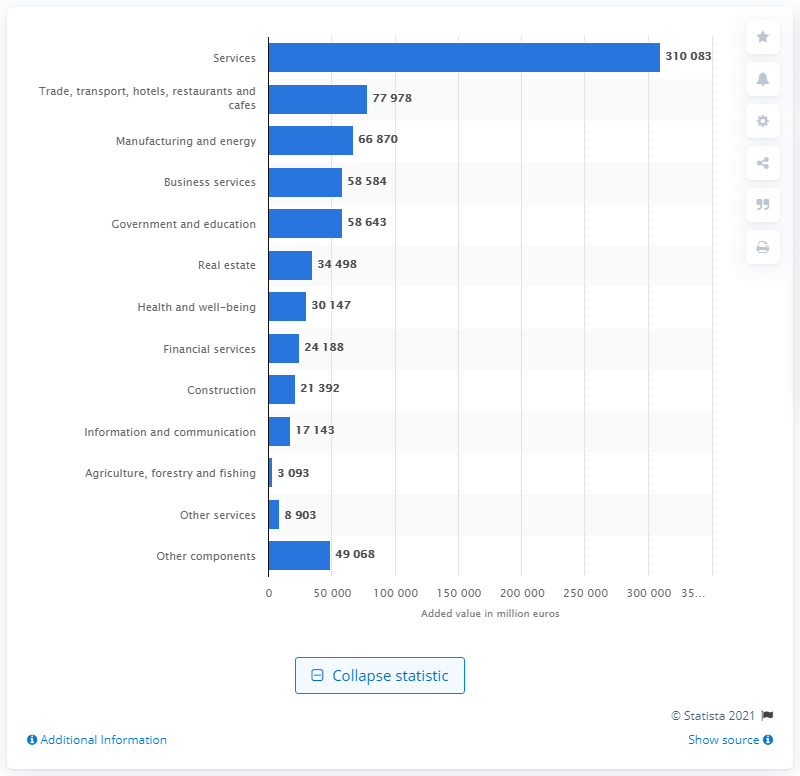Point out several critical features in this image. In 2018, the gross added value of the service sector in Belgium was 310,083. 